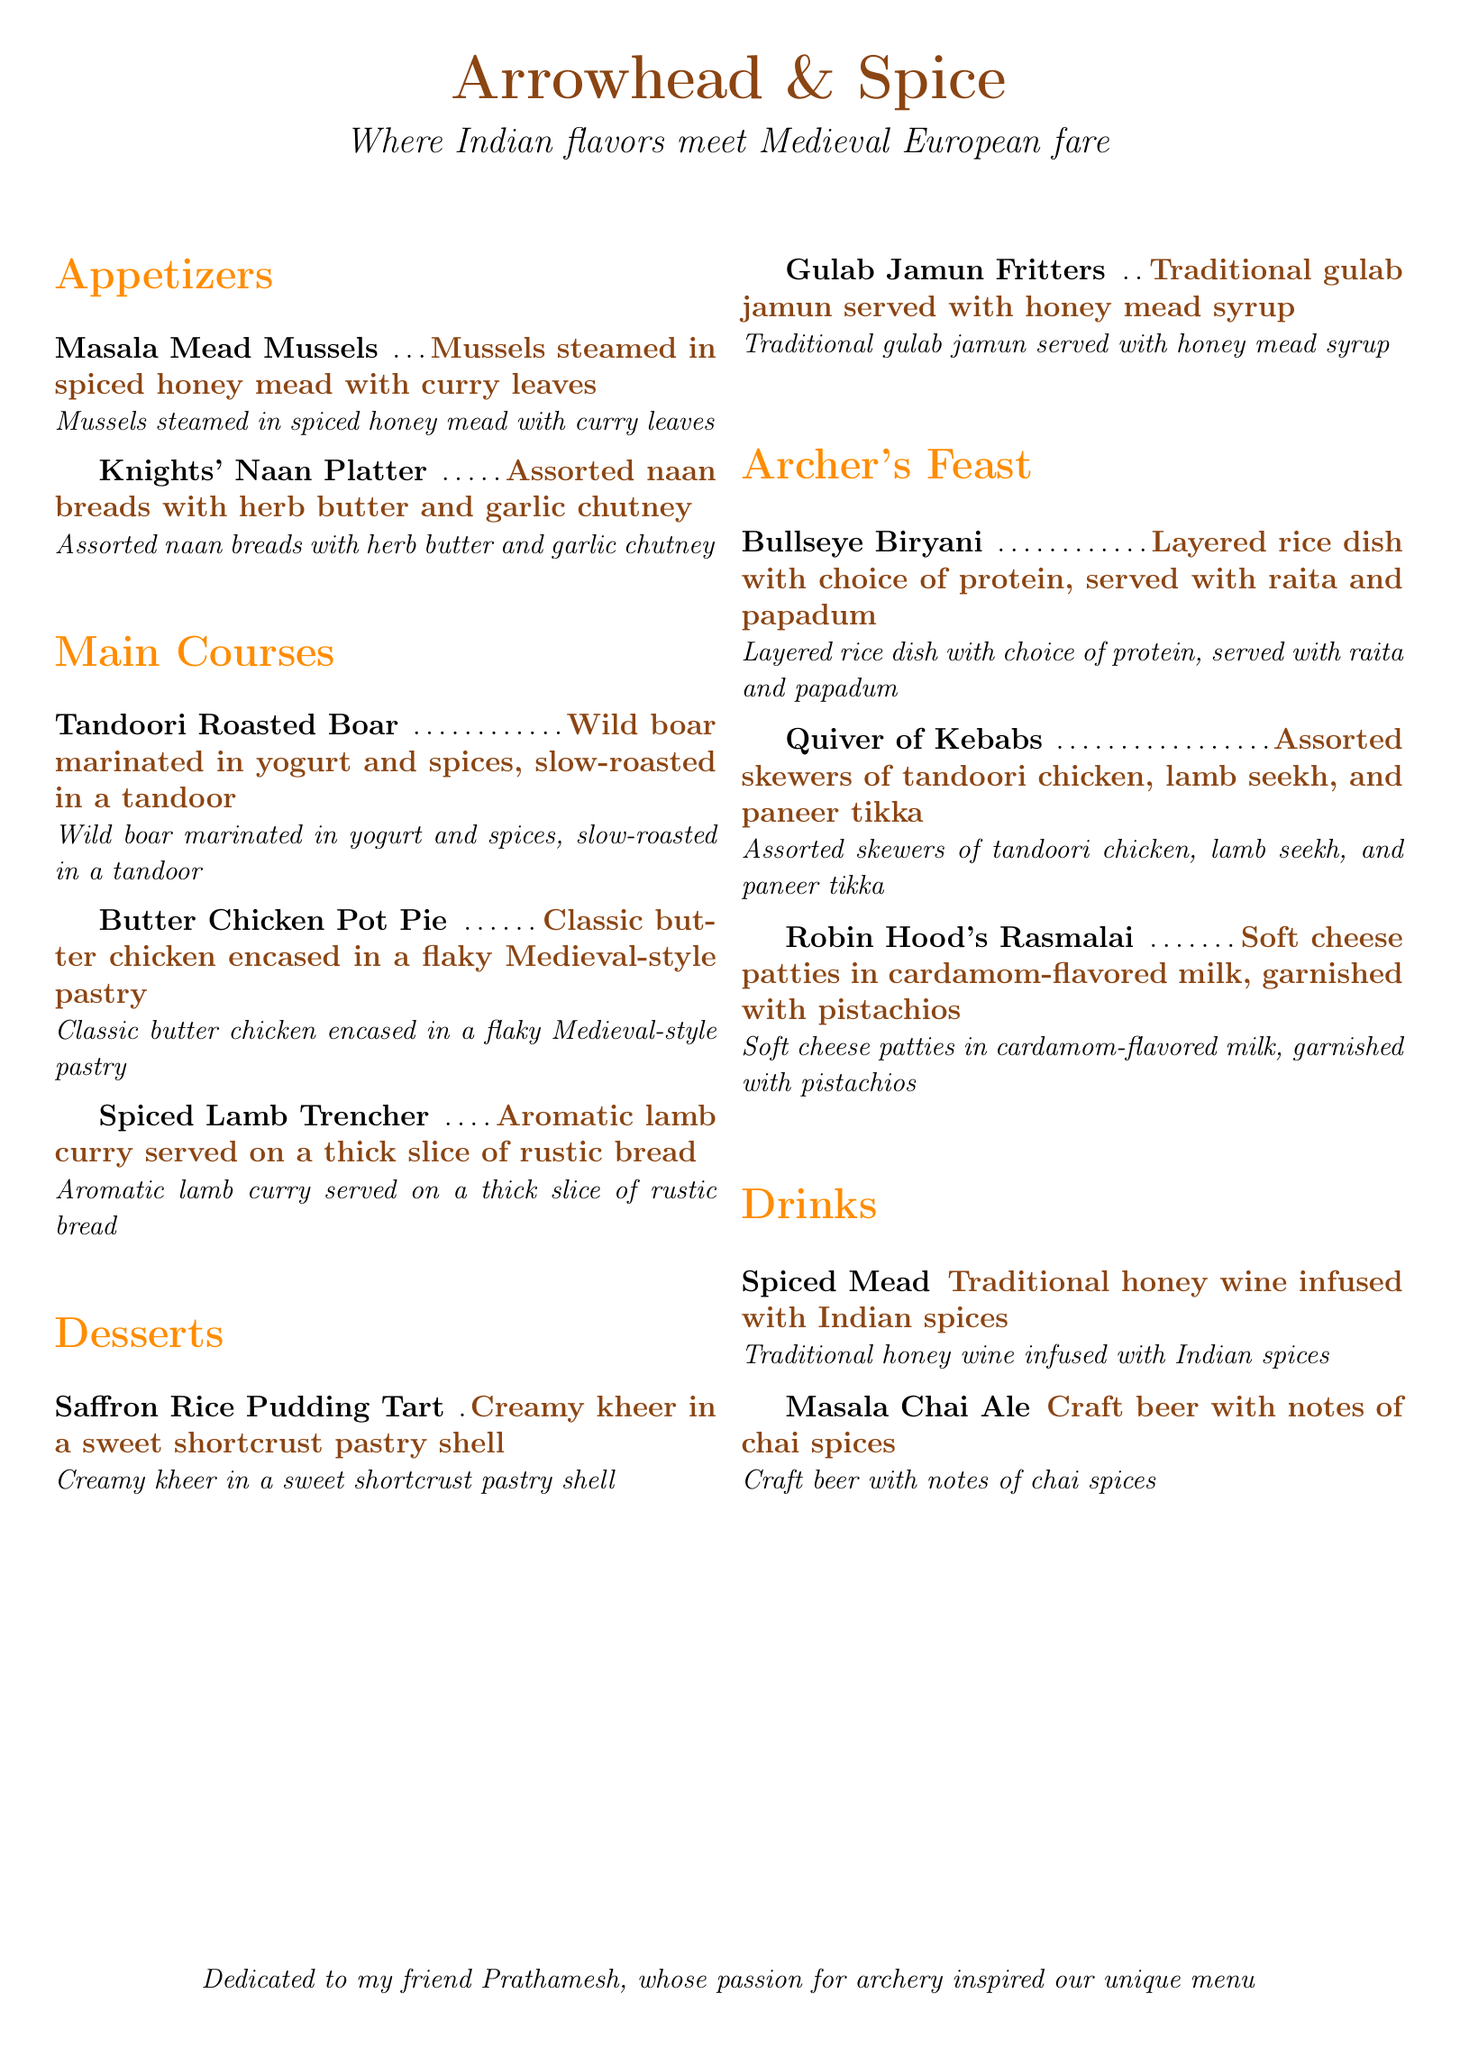What is the name of the restaurant? The restaurant's name is provided at the beginning of the document.
Answer: Arrowhead & Spice What is included in the Archer's Feast section? The Archer's Feast section features three specific dishes listed in the document.
Answer: Bullseye Biryani, Quiver of Kebabs, Robin Hood's Rasmalai What is the primary drink listed in the menu? The menu presents two types of drinks but the first one is mentioned in the drinks section.
Answer: Spiced Mead What type of cuisine does the restaurant specialize in? The document states the combination of cuisines in the opening line.
Answer: Indian and Medieval European How many appetizers are listed in the menu? The appetizers section contains a total of two specific items.
Answer: 2 What traditional dessert is served with honey mead syrup? One of the desserts clearly states it is served with honey mead syrup.
Answer: Gulab Jamun Fritters What protein options are offered with the Bullseye Biryani? The description specifies it is a layered rice dish with a choice of protein, implying multiple options without listing.
Answer: Choice of protein Which beverage combines craft beer with chai spices? The document explicitly names a beverage that includes these elements.
Answer: Masala Chai Ale What unique ingredient is used in Robin Hood's Rasmalai? The dessert description mentions a specific garnish that adds to its flavor.
Answer: Pistachios 